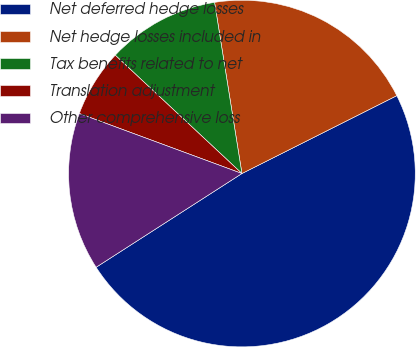Convert chart to OTSL. <chart><loc_0><loc_0><loc_500><loc_500><pie_chart><fcel>Net deferred hedge losses<fcel>Net hedge losses included in<fcel>Tax benefits related to net<fcel>Translation adjustment<fcel>Other comprehensive loss<nl><fcel>48.32%<fcel>20.11%<fcel>10.52%<fcel>6.33%<fcel>14.72%<nl></chart> 